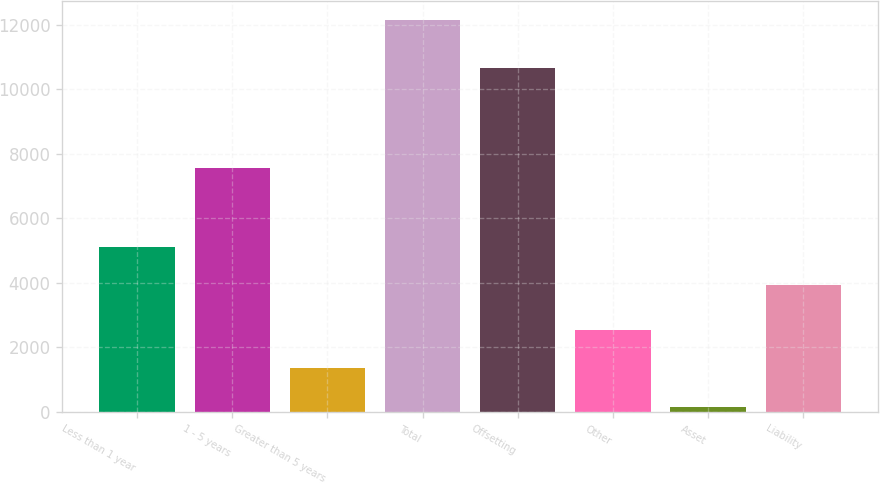Convert chart. <chart><loc_0><loc_0><loc_500><loc_500><bar_chart><fcel>Less than 1 year<fcel>1 - 5 years<fcel>Greater than 5 years<fcel>Total<fcel>Offsetting<fcel>Other<fcel>Asset<fcel>Liability<nl><fcel>5118.4<fcel>7553<fcel>1353.4<fcel>12139<fcel>10663<fcel>2551.8<fcel>155<fcel>3920<nl></chart> 